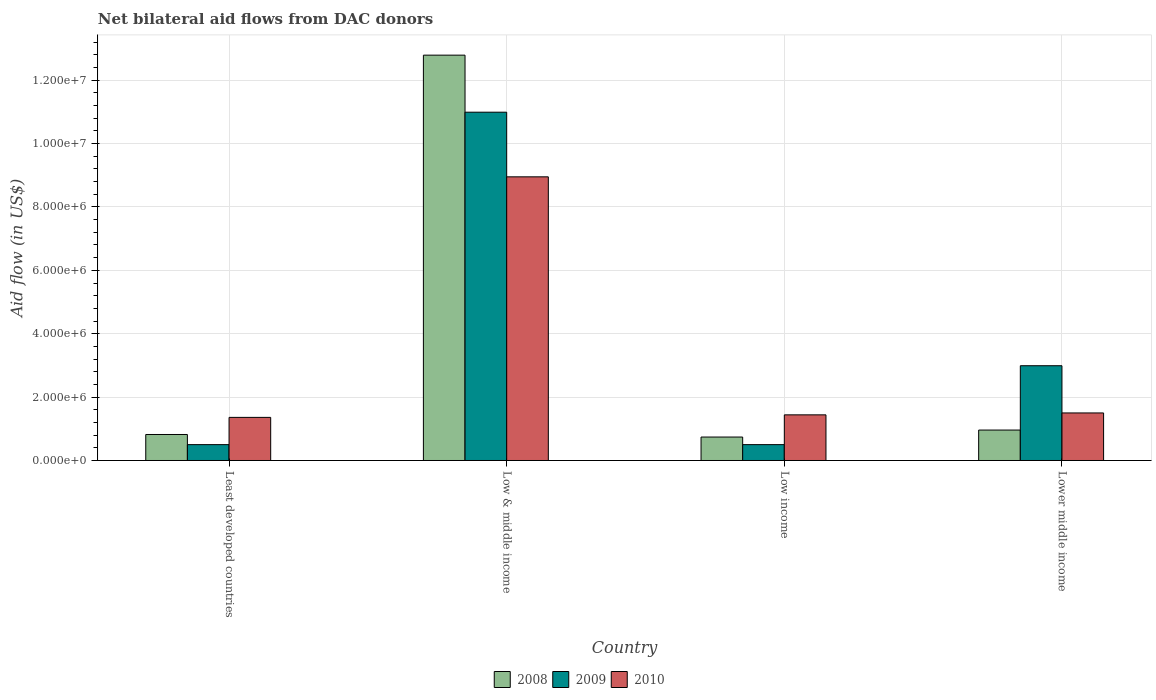How many different coloured bars are there?
Offer a terse response. 3. How many groups of bars are there?
Your answer should be very brief. 4. Are the number of bars per tick equal to the number of legend labels?
Provide a succinct answer. Yes. What is the label of the 1st group of bars from the left?
Give a very brief answer. Least developed countries. What is the net bilateral aid flow in 2009 in Lower middle income?
Your answer should be very brief. 2.99e+06. Across all countries, what is the maximum net bilateral aid flow in 2010?
Your response must be concise. 8.95e+06. Across all countries, what is the minimum net bilateral aid flow in 2010?
Make the answer very short. 1.36e+06. In which country was the net bilateral aid flow in 2009 minimum?
Ensure brevity in your answer.  Least developed countries. What is the total net bilateral aid flow in 2010 in the graph?
Provide a succinct answer. 1.32e+07. What is the difference between the net bilateral aid flow in 2008 in Low & middle income and that in Low income?
Your answer should be very brief. 1.20e+07. What is the difference between the net bilateral aid flow in 2008 in Least developed countries and the net bilateral aid flow in 2010 in Lower middle income?
Keep it short and to the point. -6.80e+05. What is the average net bilateral aid flow in 2009 per country?
Give a very brief answer. 3.74e+06. What is the difference between the net bilateral aid flow of/in 2008 and net bilateral aid flow of/in 2010 in Low & middle income?
Provide a short and direct response. 3.84e+06. In how many countries, is the net bilateral aid flow in 2009 greater than 1200000 US$?
Your response must be concise. 2. What is the ratio of the net bilateral aid flow in 2008 in Low income to that in Lower middle income?
Provide a succinct answer. 0.77. Is the difference between the net bilateral aid flow in 2008 in Low income and Lower middle income greater than the difference between the net bilateral aid flow in 2010 in Low income and Lower middle income?
Give a very brief answer. No. What is the difference between the highest and the second highest net bilateral aid flow in 2009?
Ensure brevity in your answer.  1.05e+07. What is the difference between the highest and the lowest net bilateral aid flow in 2010?
Your response must be concise. 7.59e+06. In how many countries, is the net bilateral aid flow in 2009 greater than the average net bilateral aid flow in 2009 taken over all countries?
Keep it short and to the point. 1. What does the 2nd bar from the left in Least developed countries represents?
Give a very brief answer. 2009. What does the 2nd bar from the right in Low & middle income represents?
Keep it short and to the point. 2009. Are all the bars in the graph horizontal?
Provide a short and direct response. No. Are the values on the major ticks of Y-axis written in scientific E-notation?
Provide a succinct answer. Yes. Does the graph contain grids?
Ensure brevity in your answer.  Yes. How many legend labels are there?
Provide a short and direct response. 3. What is the title of the graph?
Offer a terse response. Net bilateral aid flows from DAC donors. Does "1992" appear as one of the legend labels in the graph?
Your response must be concise. No. What is the label or title of the X-axis?
Keep it short and to the point. Country. What is the label or title of the Y-axis?
Ensure brevity in your answer.  Aid flow (in US$). What is the Aid flow (in US$) of 2008 in Least developed countries?
Offer a terse response. 8.20e+05. What is the Aid flow (in US$) in 2009 in Least developed countries?
Your response must be concise. 5.00e+05. What is the Aid flow (in US$) in 2010 in Least developed countries?
Ensure brevity in your answer.  1.36e+06. What is the Aid flow (in US$) in 2008 in Low & middle income?
Your response must be concise. 1.28e+07. What is the Aid flow (in US$) of 2009 in Low & middle income?
Your answer should be compact. 1.10e+07. What is the Aid flow (in US$) in 2010 in Low & middle income?
Make the answer very short. 8.95e+06. What is the Aid flow (in US$) in 2008 in Low income?
Your response must be concise. 7.40e+05. What is the Aid flow (in US$) in 2010 in Low income?
Your response must be concise. 1.44e+06. What is the Aid flow (in US$) of 2008 in Lower middle income?
Give a very brief answer. 9.60e+05. What is the Aid flow (in US$) in 2009 in Lower middle income?
Make the answer very short. 2.99e+06. What is the Aid flow (in US$) in 2010 in Lower middle income?
Provide a short and direct response. 1.50e+06. Across all countries, what is the maximum Aid flow (in US$) in 2008?
Your answer should be compact. 1.28e+07. Across all countries, what is the maximum Aid flow (in US$) in 2009?
Your answer should be very brief. 1.10e+07. Across all countries, what is the maximum Aid flow (in US$) of 2010?
Offer a very short reply. 8.95e+06. Across all countries, what is the minimum Aid flow (in US$) of 2008?
Make the answer very short. 7.40e+05. Across all countries, what is the minimum Aid flow (in US$) of 2009?
Your answer should be compact. 5.00e+05. Across all countries, what is the minimum Aid flow (in US$) of 2010?
Offer a terse response. 1.36e+06. What is the total Aid flow (in US$) in 2008 in the graph?
Provide a short and direct response. 1.53e+07. What is the total Aid flow (in US$) of 2009 in the graph?
Give a very brief answer. 1.50e+07. What is the total Aid flow (in US$) in 2010 in the graph?
Make the answer very short. 1.32e+07. What is the difference between the Aid flow (in US$) of 2008 in Least developed countries and that in Low & middle income?
Give a very brief answer. -1.20e+07. What is the difference between the Aid flow (in US$) in 2009 in Least developed countries and that in Low & middle income?
Your answer should be very brief. -1.05e+07. What is the difference between the Aid flow (in US$) in 2010 in Least developed countries and that in Low & middle income?
Keep it short and to the point. -7.59e+06. What is the difference between the Aid flow (in US$) in 2008 in Least developed countries and that in Low income?
Provide a succinct answer. 8.00e+04. What is the difference between the Aid flow (in US$) of 2009 in Least developed countries and that in Low income?
Make the answer very short. 0. What is the difference between the Aid flow (in US$) of 2008 in Least developed countries and that in Lower middle income?
Provide a short and direct response. -1.40e+05. What is the difference between the Aid flow (in US$) of 2009 in Least developed countries and that in Lower middle income?
Ensure brevity in your answer.  -2.49e+06. What is the difference between the Aid flow (in US$) of 2008 in Low & middle income and that in Low income?
Keep it short and to the point. 1.20e+07. What is the difference between the Aid flow (in US$) in 2009 in Low & middle income and that in Low income?
Provide a short and direct response. 1.05e+07. What is the difference between the Aid flow (in US$) of 2010 in Low & middle income and that in Low income?
Offer a terse response. 7.51e+06. What is the difference between the Aid flow (in US$) of 2008 in Low & middle income and that in Lower middle income?
Your response must be concise. 1.18e+07. What is the difference between the Aid flow (in US$) in 2009 in Low & middle income and that in Lower middle income?
Your answer should be compact. 8.00e+06. What is the difference between the Aid flow (in US$) of 2010 in Low & middle income and that in Lower middle income?
Make the answer very short. 7.45e+06. What is the difference between the Aid flow (in US$) in 2008 in Low income and that in Lower middle income?
Ensure brevity in your answer.  -2.20e+05. What is the difference between the Aid flow (in US$) in 2009 in Low income and that in Lower middle income?
Offer a very short reply. -2.49e+06. What is the difference between the Aid flow (in US$) of 2010 in Low income and that in Lower middle income?
Your answer should be compact. -6.00e+04. What is the difference between the Aid flow (in US$) in 2008 in Least developed countries and the Aid flow (in US$) in 2009 in Low & middle income?
Ensure brevity in your answer.  -1.02e+07. What is the difference between the Aid flow (in US$) in 2008 in Least developed countries and the Aid flow (in US$) in 2010 in Low & middle income?
Provide a short and direct response. -8.13e+06. What is the difference between the Aid flow (in US$) in 2009 in Least developed countries and the Aid flow (in US$) in 2010 in Low & middle income?
Give a very brief answer. -8.45e+06. What is the difference between the Aid flow (in US$) in 2008 in Least developed countries and the Aid flow (in US$) in 2010 in Low income?
Provide a succinct answer. -6.20e+05. What is the difference between the Aid flow (in US$) of 2009 in Least developed countries and the Aid flow (in US$) of 2010 in Low income?
Provide a succinct answer. -9.40e+05. What is the difference between the Aid flow (in US$) of 2008 in Least developed countries and the Aid flow (in US$) of 2009 in Lower middle income?
Make the answer very short. -2.17e+06. What is the difference between the Aid flow (in US$) of 2008 in Least developed countries and the Aid flow (in US$) of 2010 in Lower middle income?
Make the answer very short. -6.80e+05. What is the difference between the Aid flow (in US$) of 2009 in Least developed countries and the Aid flow (in US$) of 2010 in Lower middle income?
Your answer should be compact. -1.00e+06. What is the difference between the Aid flow (in US$) of 2008 in Low & middle income and the Aid flow (in US$) of 2009 in Low income?
Your response must be concise. 1.23e+07. What is the difference between the Aid flow (in US$) in 2008 in Low & middle income and the Aid flow (in US$) in 2010 in Low income?
Keep it short and to the point. 1.14e+07. What is the difference between the Aid flow (in US$) of 2009 in Low & middle income and the Aid flow (in US$) of 2010 in Low income?
Your answer should be very brief. 9.55e+06. What is the difference between the Aid flow (in US$) of 2008 in Low & middle income and the Aid flow (in US$) of 2009 in Lower middle income?
Provide a short and direct response. 9.80e+06. What is the difference between the Aid flow (in US$) of 2008 in Low & middle income and the Aid flow (in US$) of 2010 in Lower middle income?
Provide a succinct answer. 1.13e+07. What is the difference between the Aid flow (in US$) in 2009 in Low & middle income and the Aid flow (in US$) in 2010 in Lower middle income?
Provide a short and direct response. 9.49e+06. What is the difference between the Aid flow (in US$) in 2008 in Low income and the Aid flow (in US$) in 2009 in Lower middle income?
Your answer should be compact. -2.25e+06. What is the difference between the Aid flow (in US$) of 2008 in Low income and the Aid flow (in US$) of 2010 in Lower middle income?
Your answer should be very brief. -7.60e+05. What is the average Aid flow (in US$) of 2008 per country?
Your answer should be compact. 3.83e+06. What is the average Aid flow (in US$) of 2009 per country?
Provide a short and direct response. 3.74e+06. What is the average Aid flow (in US$) of 2010 per country?
Offer a very short reply. 3.31e+06. What is the difference between the Aid flow (in US$) in 2008 and Aid flow (in US$) in 2009 in Least developed countries?
Provide a succinct answer. 3.20e+05. What is the difference between the Aid flow (in US$) of 2008 and Aid flow (in US$) of 2010 in Least developed countries?
Your answer should be compact. -5.40e+05. What is the difference between the Aid flow (in US$) in 2009 and Aid flow (in US$) in 2010 in Least developed countries?
Your response must be concise. -8.60e+05. What is the difference between the Aid flow (in US$) in 2008 and Aid flow (in US$) in 2009 in Low & middle income?
Your answer should be very brief. 1.80e+06. What is the difference between the Aid flow (in US$) in 2008 and Aid flow (in US$) in 2010 in Low & middle income?
Your answer should be compact. 3.84e+06. What is the difference between the Aid flow (in US$) in 2009 and Aid flow (in US$) in 2010 in Low & middle income?
Provide a succinct answer. 2.04e+06. What is the difference between the Aid flow (in US$) in 2008 and Aid flow (in US$) in 2009 in Low income?
Provide a short and direct response. 2.40e+05. What is the difference between the Aid flow (in US$) of 2008 and Aid flow (in US$) of 2010 in Low income?
Your answer should be very brief. -7.00e+05. What is the difference between the Aid flow (in US$) of 2009 and Aid flow (in US$) of 2010 in Low income?
Your answer should be compact. -9.40e+05. What is the difference between the Aid flow (in US$) of 2008 and Aid flow (in US$) of 2009 in Lower middle income?
Your answer should be compact. -2.03e+06. What is the difference between the Aid flow (in US$) in 2008 and Aid flow (in US$) in 2010 in Lower middle income?
Provide a succinct answer. -5.40e+05. What is the difference between the Aid flow (in US$) of 2009 and Aid flow (in US$) of 2010 in Lower middle income?
Provide a succinct answer. 1.49e+06. What is the ratio of the Aid flow (in US$) in 2008 in Least developed countries to that in Low & middle income?
Your response must be concise. 0.06. What is the ratio of the Aid flow (in US$) in 2009 in Least developed countries to that in Low & middle income?
Provide a short and direct response. 0.05. What is the ratio of the Aid flow (in US$) of 2010 in Least developed countries to that in Low & middle income?
Give a very brief answer. 0.15. What is the ratio of the Aid flow (in US$) of 2008 in Least developed countries to that in Low income?
Make the answer very short. 1.11. What is the ratio of the Aid flow (in US$) of 2010 in Least developed countries to that in Low income?
Make the answer very short. 0.94. What is the ratio of the Aid flow (in US$) of 2008 in Least developed countries to that in Lower middle income?
Offer a terse response. 0.85. What is the ratio of the Aid flow (in US$) in 2009 in Least developed countries to that in Lower middle income?
Your response must be concise. 0.17. What is the ratio of the Aid flow (in US$) in 2010 in Least developed countries to that in Lower middle income?
Provide a succinct answer. 0.91. What is the ratio of the Aid flow (in US$) in 2008 in Low & middle income to that in Low income?
Your answer should be compact. 17.28. What is the ratio of the Aid flow (in US$) of 2009 in Low & middle income to that in Low income?
Give a very brief answer. 21.98. What is the ratio of the Aid flow (in US$) in 2010 in Low & middle income to that in Low income?
Give a very brief answer. 6.22. What is the ratio of the Aid flow (in US$) of 2008 in Low & middle income to that in Lower middle income?
Offer a terse response. 13.32. What is the ratio of the Aid flow (in US$) of 2009 in Low & middle income to that in Lower middle income?
Offer a very short reply. 3.68. What is the ratio of the Aid flow (in US$) of 2010 in Low & middle income to that in Lower middle income?
Offer a terse response. 5.97. What is the ratio of the Aid flow (in US$) in 2008 in Low income to that in Lower middle income?
Your answer should be very brief. 0.77. What is the ratio of the Aid flow (in US$) of 2009 in Low income to that in Lower middle income?
Your answer should be compact. 0.17. What is the ratio of the Aid flow (in US$) in 2010 in Low income to that in Lower middle income?
Provide a short and direct response. 0.96. What is the difference between the highest and the second highest Aid flow (in US$) in 2008?
Your answer should be compact. 1.18e+07. What is the difference between the highest and the second highest Aid flow (in US$) in 2009?
Your answer should be very brief. 8.00e+06. What is the difference between the highest and the second highest Aid flow (in US$) of 2010?
Ensure brevity in your answer.  7.45e+06. What is the difference between the highest and the lowest Aid flow (in US$) of 2008?
Your response must be concise. 1.20e+07. What is the difference between the highest and the lowest Aid flow (in US$) in 2009?
Make the answer very short. 1.05e+07. What is the difference between the highest and the lowest Aid flow (in US$) of 2010?
Your answer should be compact. 7.59e+06. 